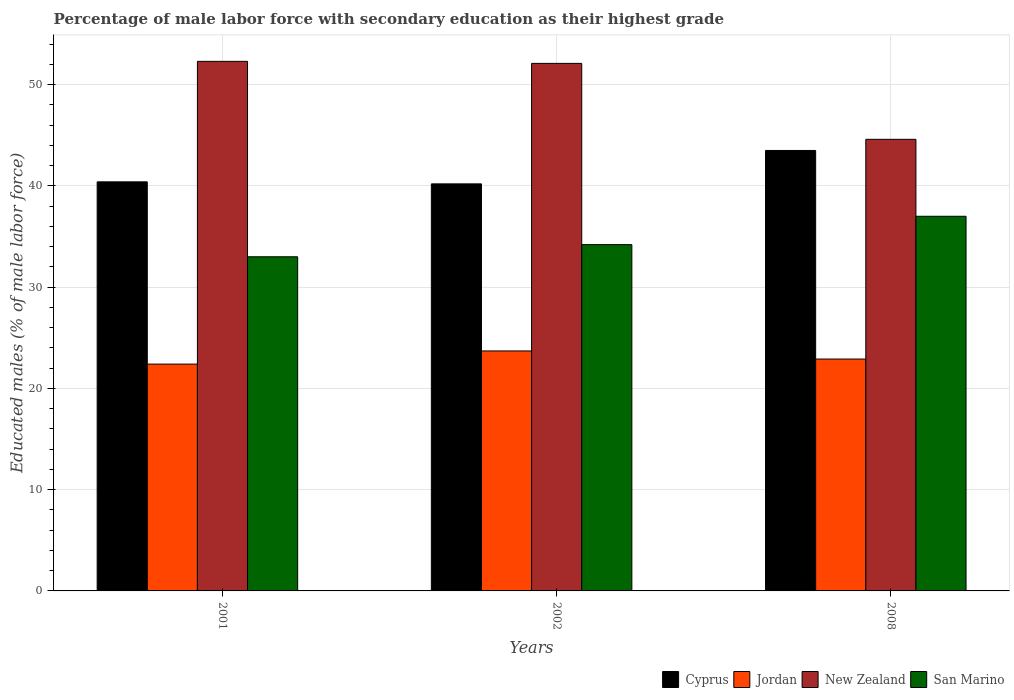How many different coloured bars are there?
Make the answer very short. 4. How many bars are there on the 1st tick from the left?
Make the answer very short. 4. In how many cases, is the number of bars for a given year not equal to the number of legend labels?
Your response must be concise. 0. What is the percentage of male labor force with secondary education in Cyprus in 2008?
Provide a succinct answer. 43.5. Across all years, what is the maximum percentage of male labor force with secondary education in San Marino?
Provide a succinct answer. 37. Across all years, what is the minimum percentage of male labor force with secondary education in New Zealand?
Provide a succinct answer. 44.6. In which year was the percentage of male labor force with secondary education in New Zealand maximum?
Keep it short and to the point. 2001. In which year was the percentage of male labor force with secondary education in San Marino minimum?
Keep it short and to the point. 2001. What is the total percentage of male labor force with secondary education in San Marino in the graph?
Offer a terse response. 104.2. What is the difference between the percentage of male labor force with secondary education in Jordan in 2002 and that in 2008?
Provide a short and direct response. 0.8. What is the difference between the percentage of male labor force with secondary education in Cyprus in 2008 and the percentage of male labor force with secondary education in San Marino in 2001?
Make the answer very short. 10.5. What is the average percentage of male labor force with secondary education in Jordan per year?
Offer a terse response. 23. In how many years, is the percentage of male labor force with secondary education in New Zealand greater than 26 %?
Your response must be concise. 3. What is the ratio of the percentage of male labor force with secondary education in San Marino in 2002 to that in 2008?
Keep it short and to the point. 0.92. What is the difference between the highest and the second highest percentage of male labor force with secondary education in New Zealand?
Give a very brief answer. 0.2. In how many years, is the percentage of male labor force with secondary education in New Zealand greater than the average percentage of male labor force with secondary education in New Zealand taken over all years?
Provide a succinct answer. 2. Is the sum of the percentage of male labor force with secondary education in New Zealand in 2001 and 2008 greater than the maximum percentage of male labor force with secondary education in San Marino across all years?
Your response must be concise. Yes. Is it the case that in every year, the sum of the percentage of male labor force with secondary education in San Marino and percentage of male labor force with secondary education in Cyprus is greater than the sum of percentage of male labor force with secondary education in New Zealand and percentage of male labor force with secondary education in Jordan?
Keep it short and to the point. No. What does the 2nd bar from the left in 2008 represents?
Make the answer very short. Jordan. What does the 1st bar from the right in 2002 represents?
Make the answer very short. San Marino. Is it the case that in every year, the sum of the percentage of male labor force with secondary education in New Zealand and percentage of male labor force with secondary education in Jordan is greater than the percentage of male labor force with secondary education in Cyprus?
Ensure brevity in your answer.  Yes. Are all the bars in the graph horizontal?
Keep it short and to the point. No. What is the difference between two consecutive major ticks on the Y-axis?
Ensure brevity in your answer.  10. Does the graph contain any zero values?
Offer a terse response. No. Where does the legend appear in the graph?
Provide a short and direct response. Bottom right. How are the legend labels stacked?
Offer a very short reply. Horizontal. What is the title of the graph?
Provide a short and direct response. Percentage of male labor force with secondary education as their highest grade. What is the label or title of the X-axis?
Keep it short and to the point. Years. What is the label or title of the Y-axis?
Make the answer very short. Educated males (% of male labor force). What is the Educated males (% of male labor force) of Cyprus in 2001?
Your answer should be compact. 40.4. What is the Educated males (% of male labor force) of Jordan in 2001?
Give a very brief answer. 22.4. What is the Educated males (% of male labor force) in New Zealand in 2001?
Provide a short and direct response. 52.3. What is the Educated males (% of male labor force) of San Marino in 2001?
Your response must be concise. 33. What is the Educated males (% of male labor force) of Cyprus in 2002?
Keep it short and to the point. 40.2. What is the Educated males (% of male labor force) of Jordan in 2002?
Make the answer very short. 23.7. What is the Educated males (% of male labor force) in New Zealand in 2002?
Offer a very short reply. 52.1. What is the Educated males (% of male labor force) in San Marino in 2002?
Give a very brief answer. 34.2. What is the Educated males (% of male labor force) of Cyprus in 2008?
Your answer should be compact. 43.5. What is the Educated males (% of male labor force) of Jordan in 2008?
Your response must be concise. 22.9. What is the Educated males (% of male labor force) of New Zealand in 2008?
Keep it short and to the point. 44.6. Across all years, what is the maximum Educated males (% of male labor force) in Cyprus?
Provide a succinct answer. 43.5. Across all years, what is the maximum Educated males (% of male labor force) of Jordan?
Ensure brevity in your answer.  23.7. Across all years, what is the maximum Educated males (% of male labor force) in New Zealand?
Give a very brief answer. 52.3. Across all years, what is the maximum Educated males (% of male labor force) of San Marino?
Offer a terse response. 37. Across all years, what is the minimum Educated males (% of male labor force) in Cyprus?
Your answer should be very brief. 40.2. Across all years, what is the minimum Educated males (% of male labor force) in Jordan?
Your answer should be compact. 22.4. Across all years, what is the minimum Educated males (% of male labor force) of New Zealand?
Your response must be concise. 44.6. What is the total Educated males (% of male labor force) in Cyprus in the graph?
Provide a short and direct response. 124.1. What is the total Educated males (% of male labor force) of Jordan in the graph?
Your answer should be very brief. 69. What is the total Educated males (% of male labor force) in New Zealand in the graph?
Offer a very short reply. 149. What is the total Educated males (% of male labor force) of San Marino in the graph?
Your response must be concise. 104.2. What is the difference between the Educated males (% of male labor force) of Jordan in 2001 and that in 2002?
Offer a terse response. -1.3. What is the difference between the Educated males (% of male labor force) in San Marino in 2001 and that in 2002?
Keep it short and to the point. -1.2. What is the difference between the Educated males (% of male labor force) in Cyprus in 2001 and that in 2008?
Give a very brief answer. -3.1. What is the difference between the Educated males (% of male labor force) in New Zealand in 2001 and that in 2008?
Ensure brevity in your answer.  7.7. What is the difference between the Educated males (% of male labor force) in Cyprus in 2002 and that in 2008?
Offer a very short reply. -3.3. What is the difference between the Educated males (% of male labor force) in Jordan in 2002 and that in 2008?
Your response must be concise. 0.8. What is the difference between the Educated males (% of male labor force) in New Zealand in 2002 and that in 2008?
Your answer should be very brief. 7.5. What is the difference between the Educated males (% of male labor force) in Cyprus in 2001 and the Educated males (% of male labor force) in New Zealand in 2002?
Give a very brief answer. -11.7. What is the difference between the Educated males (% of male labor force) in Jordan in 2001 and the Educated males (% of male labor force) in New Zealand in 2002?
Your response must be concise. -29.7. What is the difference between the Educated males (% of male labor force) of Jordan in 2001 and the Educated males (% of male labor force) of San Marino in 2002?
Ensure brevity in your answer.  -11.8. What is the difference between the Educated males (% of male labor force) in Cyprus in 2001 and the Educated males (% of male labor force) in Jordan in 2008?
Your answer should be very brief. 17.5. What is the difference between the Educated males (% of male labor force) of Cyprus in 2001 and the Educated males (% of male labor force) of San Marino in 2008?
Your answer should be very brief. 3.4. What is the difference between the Educated males (% of male labor force) of Jordan in 2001 and the Educated males (% of male labor force) of New Zealand in 2008?
Keep it short and to the point. -22.2. What is the difference between the Educated males (% of male labor force) of Jordan in 2001 and the Educated males (% of male labor force) of San Marino in 2008?
Ensure brevity in your answer.  -14.6. What is the difference between the Educated males (% of male labor force) in Cyprus in 2002 and the Educated males (% of male labor force) in San Marino in 2008?
Your answer should be very brief. 3.2. What is the difference between the Educated males (% of male labor force) in Jordan in 2002 and the Educated males (% of male labor force) in New Zealand in 2008?
Your answer should be compact. -20.9. What is the difference between the Educated males (% of male labor force) in Jordan in 2002 and the Educated males (% of male labor force) in San Marino in 2008?
Ensure brevity in your answer.  -13.3. What is the difference between the Educated males (% of male labor force) in New Zealand in 2002 and the Educated males (% of male labor force) in San Marino in 2008?
Your answer should be compact. 15.1. What is the average Educated males (% of male labor force) of Cyprus per year?
Keep it short and to the point. 41.37. What is the average Educated males (% of male labor force) of New Zealand per year?
Provide a short and direct response. 49.67. What is the average Educated males (% of male labor force) of San Marino per year?
Provide a succinct answer. 34.73. In the year 2001, what is the difference between the Educated males (% of male labor force) of Cyprus and Educated males (% of male labor force) of Jordan?
Provide a short and direct response. 18. In the year 2001, what is the difference between the Educated males (% of male labor force) in Cyprus and Educated males (% of male labor force) in New Zealand?
Offer a very short reply. -11.9. In the year 2001, what is the difference between the Educated males (% of male labor force) in Cyprus and Educated males (% of male labor force) in San Marino?
Offer a terse response. 7.4. In the year 2001, what is the difference between the Educated males (% of male labor force) in Jordan and Educated males (% of male labor force) in New Zealand?
Ensure brevity in your answer.  -29.9. In the year 2001, what is the difference between the Educated males (% of male labor force) of New Zealand and Educated males (% of male labor force) of San Marino?
Your answer should be very brief. 19.3. In the year 2002, what is the difference between the Educated males (% of male labor force) in Cyprus and Educated males (% of male labor force) in New Zealand?
Keep it short and to the point. -11.9. In the year 2002, what is the difference between the Educated males (% of male labor force) of Jordan and Educated males (% of male labor force) of New Zealand?
Your answer should be very brief. -28.4. In the year 2008, what is the difference between the Educated males (% of male labor force) of Cyprus and Educated males (% of male labor force) of Jordan?
Offer a terse response. 20.6. In the year 2008, what is the difference between the Educated males (% of male labor force) in Cyprus and Educated males (% of male labor force) in New Zealand?
Your answer should be compact. -1.1. In the year 2008, what is the difference between the Educated males (% of male labor force) in Cyprus and Educated males (% of male labor force) in San Marino?
Offer a terse response. 6.5. In the year 2008, what is the difference between the Educated males (% of male labor force) of Jordan and Educated males (% of male labor force) of New Zealand?
Provide a short and direct response. -21.7. In the year 2008, what is the difference between the Educated males (% of male labor force) of Jordan and Educated males (% of male labor force) of San Marino?
Offer a terse response. -14.1. In the year 2008, what is the difference between the Educated males (% of male labor force) of New Zealand and Educated males (% of male labor force) of San Marino?
Your answer should be very brief. 7.6. What is the ratio of the Educated males (% of male labor force) of Jordan in 2001 to that in 2002?
Your answer should be very brief. 0.95. What is the ratio of the Educated males (% of male labor force) in New Zealand in 2001 to that in 2002?
Your answer should be compact. 1. What is the ratio of the Educated males (% of male labor force) in San Marino in 2001 to that in 2002?
Keep it short and to the point. 0.96. What is the ratio of the Educated males (% of male labor force) of Cyprus in 2001 to that in 2008?
Make the answer very short. 0.93. What is the ratio of the Educated males (% of male labor force) in Jordan in 2001 to that in 2008?
Your response must be concise. 0.98. What is the ratio of the Educated males (% of male labor force) of New Zealand in 2001 to that in 2008?
Offer a very short reply. 1.17. What is the ratio of the Educated males (% of male labor force) of San Marino in 2001 to that in 2008?
Keep it short and to the point. 0.89. What is the ratio of the Educated males (% of male labor force) of Cyprus in 2002 to that in 2008?
Your answer should be compact. 0.92. What is the ratio of the Educated males (% of male labor force) in Jordan in 2002 to that in 2008?
Keep it short and to the point. 1.03. What is the ratio of the Educated males (% of male labor force) of New Zealand in 2002 to that in 2008?
Offer a terse response. 1.17. What is the ratio of the Educated males (% of male labor force) of San Marino in 2002 to that in 2008?
Your answer should be very brief. 0.92. What is the difference between the highest and the second highest Educated males (% of male labor force) of Jordan?
Offer a terse response. 0.8. What is the difference between the highest and the second highest Educated males (% of male labor force) in San Marino?
Provide a short and direct response. 2.8. What is the difference between the highest and the lowest Educated males (% of male labor force) in New Zealand?
Provide a short and direct response. 7.7. What is the difference between the highest and the lowest Educated males (% of male labor force) of San Marino?
Make the answer very short. 4. 